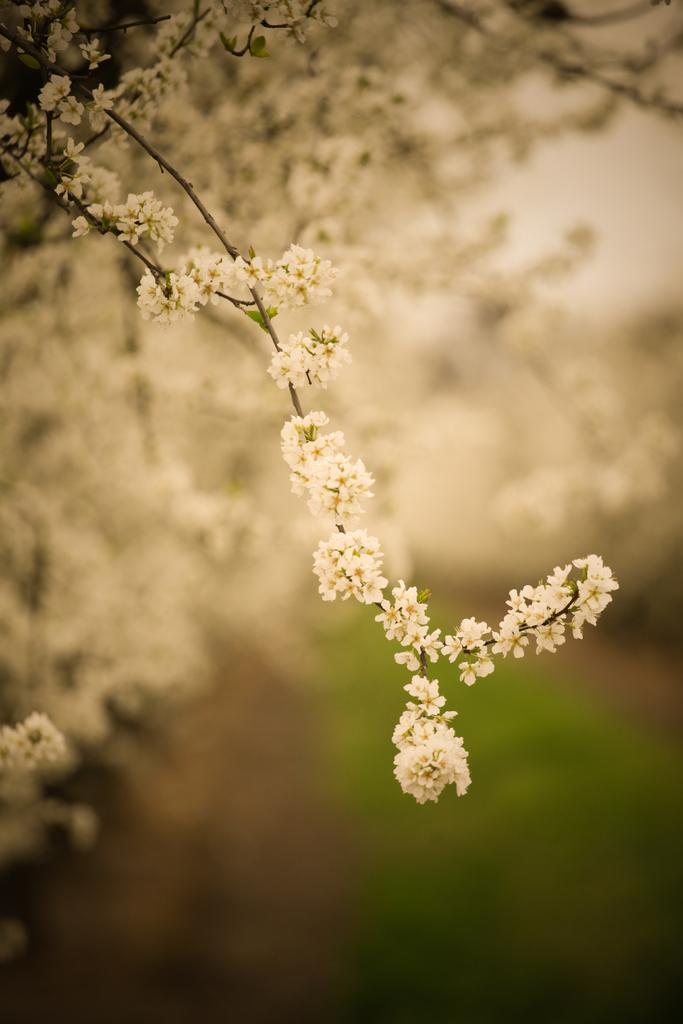Please provide a concise description of this image. In this picture we can see few flowers, grass and blurry background. 